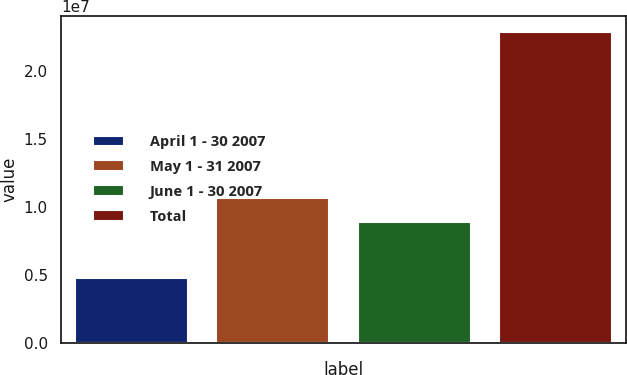Convert chart. <chart><loc_0><loc_0><loc_500><loc_500><bar_chart><fcel>April 1 - 30 2007<fcel>May 1 - 31 2007<fcel>June 1 - 30 2007<fcel>Total<nl><fcel>4.75806e+06<fcel>1.06605e+07<fcel>8.84913e+06<fcel>2.2872e+07<nl></chart> 